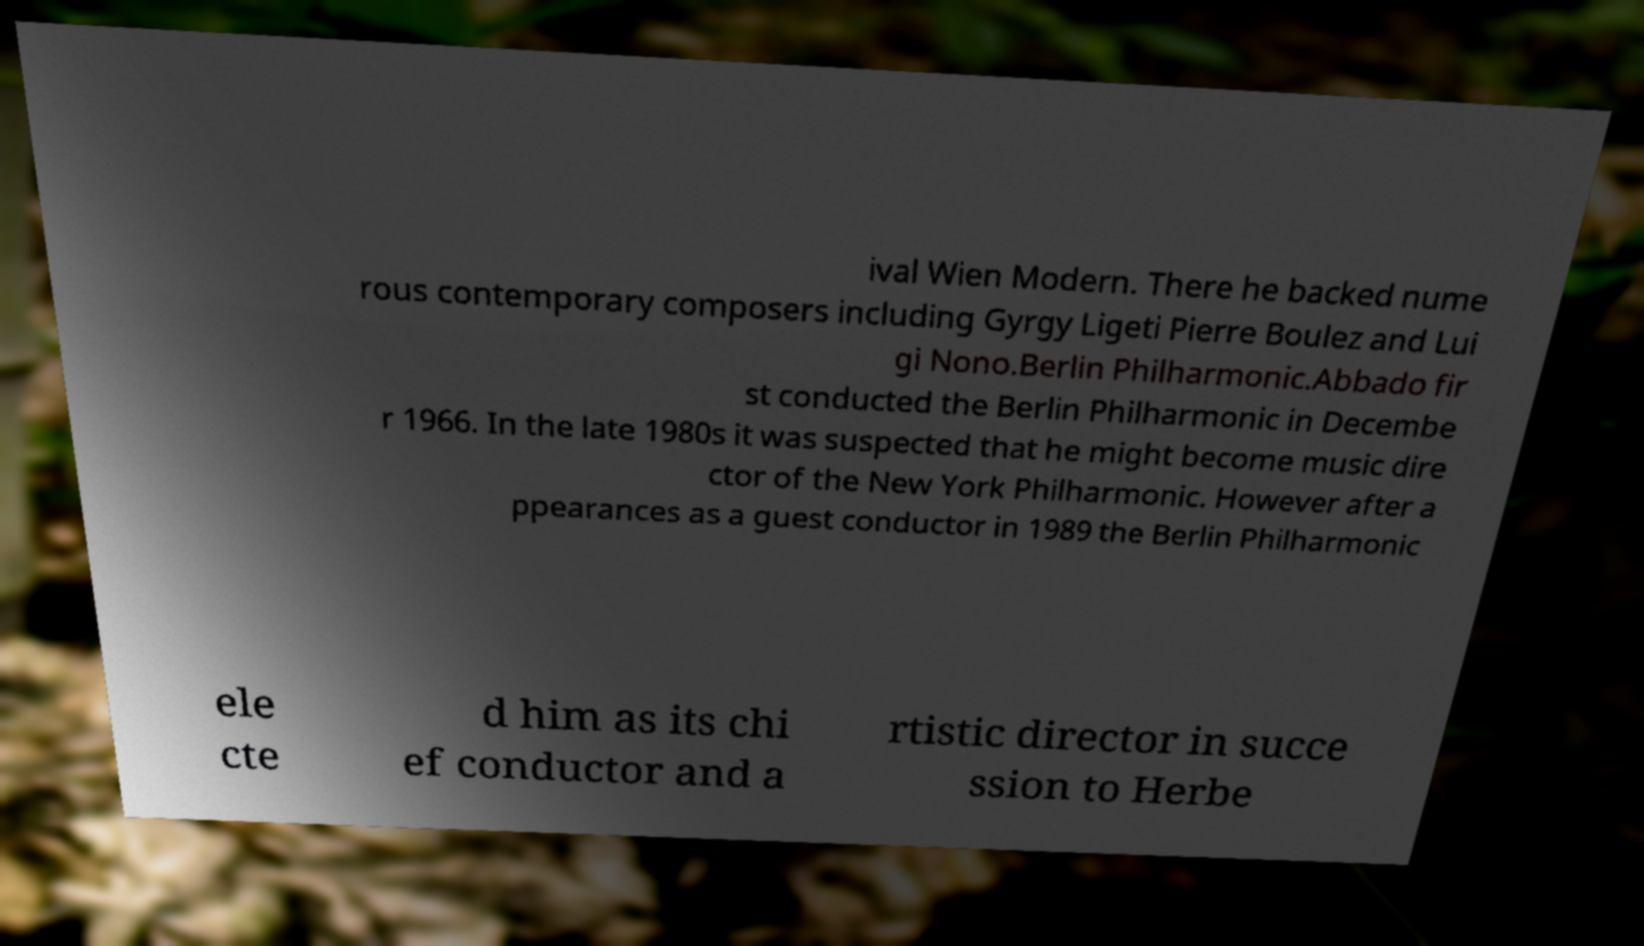What messages or text are displayed in this image? I need them in a readable, typed format. ival Wien Modern. There he backed nume rous contemporary composers including Gyrgy Ligeti Pierre Boulez and Lui gi Nono.Berlin Philharmonic.Abbado fir st conducted the Berlin Philharmonic in Decembe r 1966. In the late 1980s it was suspected that he might become music dire ctor of the New York Philharmonic. However after a ppearances as a guest conductor in 1989 the Berlin Philharmonic ele cte d him as its chi ef conductor and a rtistic director in succe ssion to Herbe 